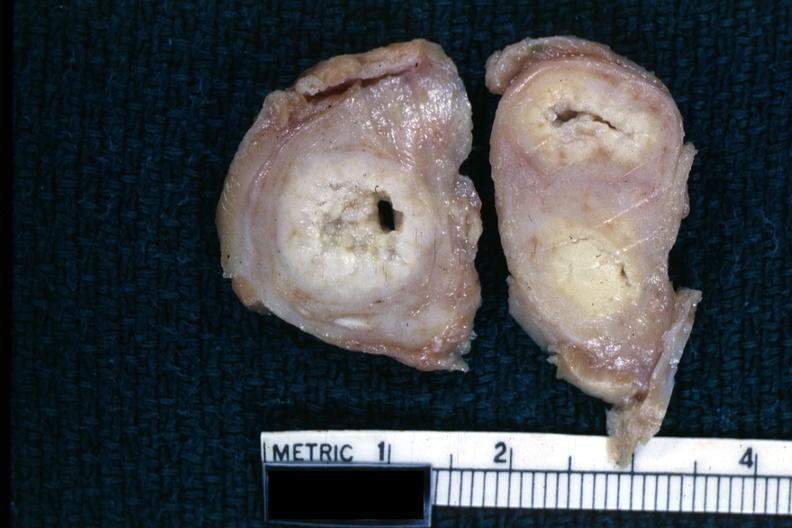what is present?
Answer the question using a single word or phrase. Female reproductive 